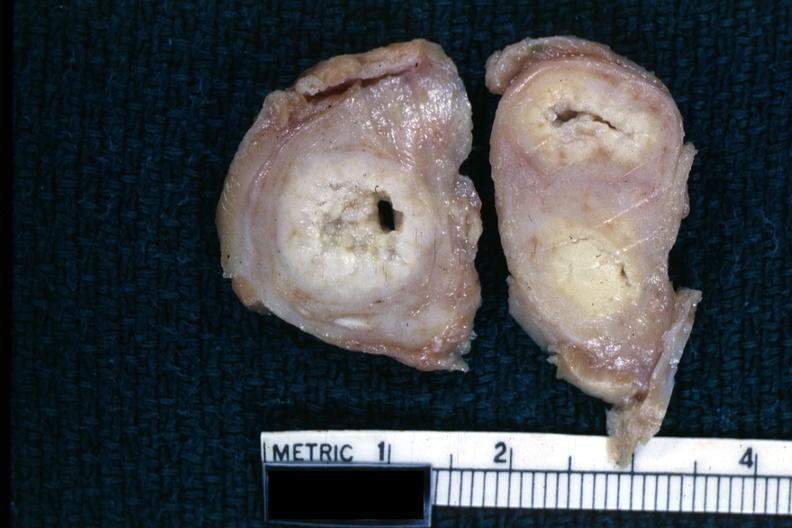what is present?
Answer the question using a single word or phrase. Female reproductive 